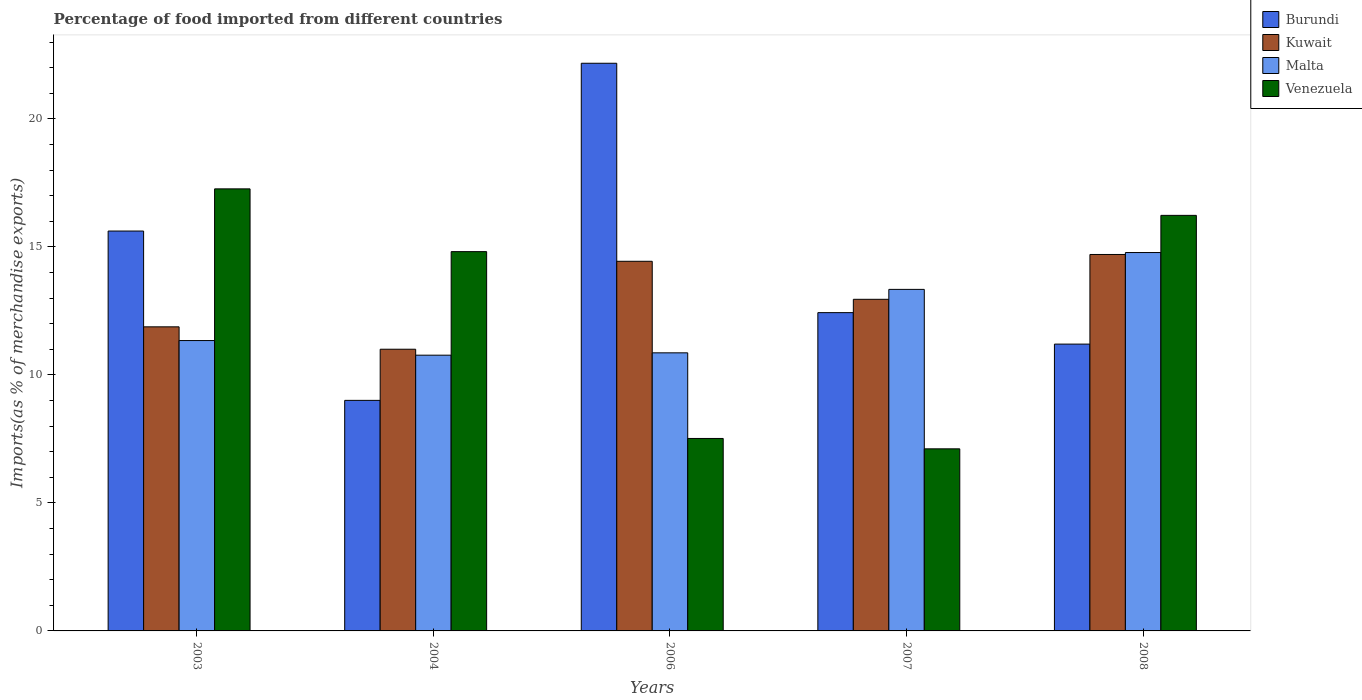How many groups of bars are there?
Make the answer very short. 5. Are the number of bars on each tick of the X-axis equal?
Ensure brevity in your answer.  Yes. How many bars are there on the 2nd tick from the right?
Your response must be concise. 4. What is the label of the 3rd group of bars from the left?
Your answer should be compact. 2006. In how many cases, is the number of bars for a given year not equal to the number of legend labels?
Provide a succinct answer. 0. What is the percentage of imports to different countries in Malta in 2003?
Ensure brevity in your answer.  11.34. Across all years, what is the maximum percentage of imports to different countries in Burundi?
Your answer should be compact. 22.17. Across all years, what is the minimum percentage of imports to different countries in Burundi?
Keep it short and to the point. 9. In which year was the percentage of imports to different countries in Venezuela minimum?
Provide a short and direct response. 2007. What is the total percentage of imports to different countries in Kuwait in the graph?
Provide a succinct answer. 64.97. What is the difference between the percentage of imports to different countries in Kuwait in 2004 and that in 2008?
Make the answer very short. -3.7. What is the difference between the percentage of imports to different countries in Kuwait in 2007 and the percentage of imports to different countries in Burundi in 2008?
Your answer should be very brief. 1.75. What is the average percentage of imports to different countries in Kuwait per year?
Offer a very short reply. 12.99. In the year 2008, what is the difference between the percentage of imports to different countries in Burundi and percentage of imports to different countries in Venezuela?
Your answer should be very brief. -5.03. In how many years, is the percentage of imports to different countries in Venezuela greater than 1 %?
Ensure brevity in your answer.  5. What is the ratio of the percentage of imports to different countries in Kuwait in 2006 to that in 2008?
Offer a very short reply. 0.98. Is the difference between the percentage of imports to different countries in Burundi in 2004 and 2008 greater than the difference between the percentage of imports to different countries in Venezuela in 2004 and 2008?
Ensure brevity in your answer.  No. What is the difference between the highest and the second highest percentage of imports to different countries in Burundi?
Give a very brief answer. 6.55. What is the difference between the highest and the lowest percentage of imports to different countries in Kuwait?
Give a very brief answer. 3.7. What does the 3rd bar from the left in 2008 represents?
Provide a short and direct response. Malta. What does the 2nd bar from the right in 2006 represents?
Give a very brief answer. Malta. How many bars are there?
Keep it short and to the point. 20. Are the values on the major ticks of Y-axis written in scientific E-notation?
Make the answer very short. No. Does the graph contain any zero values?
Give a very brief answer. No. Where does the legend appear in the graph?
Your answer should be very brief. Top right. How many legend labels are there?
Provide a short and direct response. 4. How are the legend labels stacked?
Your response must be concise. Vertical. What is the title of the graph?
Make the answer very short. Percentage of food imported from different countries. Does "Timor-Leste" appear as one of the legend labels in the graph?
Your answer should be compact. No. What is the label or title of the Y-axis?
Provide a short and direct response. Imports(as % of merchandise exports). What is the Imports(as % of merchandise exports) of Burundi in 2003?
Provide a succinct answer. 15.62. What is the Imports(as % of merchandise exports) in Kuwait in 2003?
Offer a very short reply. 11.88. What is the Imports(as % of merchandise exports) of Malta in 2003?
Provide a short and direct response. 11.34. What is the Imports(as % of merchandise exports) in Venezuela in 2003?
Provide a succinct answer. 17.26. What is the Imports(as % of merchandise exports) of Burundi in 2004?
Provide a short and direct response. 9. What is the Imports(as % of merchandise exports) in Kuwait in 2004?
Your answer should be compact. 11. What is the Imports(as % of merchandise exports) in Malta in 2004?
Your answer should be very brief. 10.77. What is the Imports(as % of merchandise exports) in Venezuela in 2004?
Give a very brief answer. 14.81. What is the Imports(as % of merchandise exports) in Burundi in 2006?
Offer a terse response. 22.17. What is the Imports(as % of merchandise exports) of Kuwait in 2006?
Make the answer very short. 14.44. What is the Imports(as % of merchandise exports) in Malta in 2006?
Offer a very short reply. 10.86. What is the Imports(as % of merchandise exports) in Venezuela in 2006?
Your answer should be very brief. 7.52. What is the Imports(as % of merchandise exports) in Burundi in 2007?
Ensure brevity in your answer.  12.43. What is the Imports(as % of merchandise exports) in Kuwait in 2007?
Your answer should be compact. 12.95. What is the Imports(as % of merchandise exports) of Malta in 2007?
Offer a very short reply. 13.34. What is the Imports(as % of merchandise exports) of Venezuela in 2007?
Offer a very short reply. 7.11. What is the Imports(as % of merchandise exports) in Burundi in 2008?
Give a very brief answer. 11.2. What is the Imports(as % of merchandise exports) in Kuwait in 2008?
Give a very brief answer. 14.7. What is the Imports(as % of merchandise exports) of Malta in 2008?
Keep it short and to the point. 14.78. What is the Imports(as % of merchandise exports) in Venezuela in 2008?
Keep it short and to the point. 16.23. Across all years, what is the maximum Imports(as % of merchandise exports) of Burundi?
Your answer should be very brief. 22.17. Across all years, what is the maximum Imports(as % of merchandise exports) of Kuwait?
Offer a very short reply. 14.7. Across all years, what is the maximum Imports(as % of merchandise exports) of Malta?
Give a very brief answer. 14.78. Across all years, what is the maximum Imports(as % of merchandise exports) in Venezuela?
Your answer should be very brief. 17.26. Across all years, what is the minimum Imports(as % of merchandise exports) of Burundi?
Make the answer very short. 9. Across all years, what is the minimum Imports(as % of merchandise exports) of Kuwait?
Provide a short and direct response. 11. Across all years, what is the minimum Imports(as % of merchandise exports) of Malta?
Provide a succinct answer. 10.77. Across all years, what is the minimum Imports(as % of merchandise exports) in Venezuela?
Your response must be concise. 7.11. What is the total Imports(as % of merchandise exports) of Burundi in the graph?
Offer a very short reply. 70.42. What is the total Imports(as % of merchandise exports) in Kuwait in the graph?
Your response must be concise. 64.97. What is the total Imports(as % of merchandise exports) of Malta in the graph?
Your answer should be compact. 61.09. What is the total Imports(as % of merchandise exports) in Venezuela in the graph?
Make the answer very short. 62.94. What is the difference between the Imports(as % of merchandise exports) in Burundi in 2003 and that in 2004?
Offer a terse response. 6.61. What is the difference between the Imports(as % of merchandise exports) in Kuwait in 2003 and that in 2004?
Provide a short and direct response. 0.87. What is the difference between the Imports(as % of merchandise exports) of Malta in 2003 and that in 2004?
Offer a terse response. 0.57. What is the difference between the Imports(as % of merchandise exports) of Venezuela in 2003 and that in 2004?
Make the answer very short. 2.45. What is the difference between the Imports(as % of merchandise exports) in Burundi in 2003 and that in 2006?
Provide a succinct answer. -6.55. What is the difference between the Imports(as % of merchandise exports) in Kuwait in 2003 and that in 2006?
Your answer should be very brief. -2.56. What is the difference between the Imports(as % of merchandise exports) of Malta in 2003 and that in 2006?
Keep it short and to the point. 0.48. What is the difference between the Imports(as % of merchandise exports) of Venezuela in 2003 and that in 2006?
Offer a very short reply. 9.75. What is the difference between the Imports(as % of merchandise exports) of Burundi in 2003 and that in 2007?
Provide a succinct answer. 3.19. What is the difference between the Imports(as % of merchandise exports) of Kuwait in 2003 and that in 2007?
Give a very brief answer. -1.08. What is the difference between the Imports(as % of merchandise exports) of Malta in 2003 and that in 2007?
Make the answer very short. -2. What is the difference between the Imports(as % of merchandise exports) of Venezuela in 2003 and that in 2007?
Your answer should be compact. 10.15. What is the difference between the Imports(as % of merchandise exports) in Burundi in 2003 and that in 2008?
Keep it short and to the point. 4.42. What is the difference between the Imports(as % of merchandise exports) of Kuwait in 2003 and that in 2008?
Provide a succinct answer. -2.83. What is the difference between the Imports(as % of merchandise exports) of Malta in 2003 and that in 2008?
Give a very brief answer. -3.44. What is the difference between the Imports(as % of merchandise exports) in Venezuela in 2003 and that in 2008?
Give a very brief answer. 1.03. What is the difference between the Imports(as % of merchandise exports) in Burundi in 2004 and that in 2006?
Provide a succinct answer. -13.17. What is the difference between the Imports(as % of merchandise exports) in Kuwait in 2004 and that in 2006?
Offer a terse response. -3.43. What is the difference between the Imports(as % of merchandise exports) in Malta in 2004 and that in 2006?
Provide a short and direct response. -0.09. What is the difference between the Imports(as % of merchandise exports) of Venezuela in 2004 and that in 2006?
Provide a short and direct response. 7.3. What is the difference between the Imports(as % of merchandise exports) in Burundi in 2004 and that in 2007?
Your answer should be compact. -3.43. What is the difference between the Imports(as % of merchandise exports) in Kuwait in 2004 and that in 2007?
Keep it short and to the point. -1.95. What is the difference between the Imports(as % of merchandise exports) of Malta in 2004 and that in 2007?
Your answer should be very brief. -2.57. What is the difference between the Imports(as % of merchandise exports) of Venezuela in 2004 and that in 2007?
Offer a very short reply. 7.7. What is the difference between the Imports(as % of merchandise exports) of Burundi in 2004 and that in 2008?
Offer a terse response. -2.2. What is the difference between the Imports(as % of merchandise exports) in Kuwait in 2004 and that in 2008?
Provide a succinct answer. -3.7. What is the difference between the Imports(as % of merchandise exports) in Malta in 2004 and that in 2008?
Offer a very short reply. -4.01. What is the difference between the Imports(as % of merchandise exports) of Venezuela in 2004 and that in 2008?
Provide a short and direct response. -1.42. What is the difference between the Imports(as % of merchandise exports) of Burundi in 2006 and that in 2007?
Give a very brief answer. 9.74. What is the difference between the Imports(as % of merchandise exports) in Kuwait in 2006 and that in 2007?
Keep it short and to the point. 1.48. What is the difference between the Imports(as % of merchandise exports) in Malta in 2006 and that in 2007?
Offer a terse response. -2.48. What is the difference between the Imports(as % of merchandise exports) of Venezuela in 2006 and that in 2007?
Ensure brevity in your answer.  0.41. What is the difference between the Imports(as % of merchandise exports) of Burundi in 2006 and that in 2008?
Give a very brief answer. 10.97. What is the difference between the Imports(as % of merchandise exports) in Kuwait in 2006 and that in 2008?
Offer a very short reply. -0.27. What is the difference between the Imports(as % of merchandise exports) in Malta in 2006 and that in 2008?
Offer a terse response. -3.92. What is the difference between the Imports(as % of merchandise exports) of Venezuela in 2006 and that in 2008?
Your answer should be compact. -8.71. What is the difference between the Imports(as % of merchandise exports) of Burundi in 2007 and that in 2008?
Offer a very short reply. 1.23. What is the difference between the Imports(as % of merchandise exports) of Kuwait in 2007 and that in 2008?
Ensure brevity in your answer.  -1.75. What is the difference between the Imports(as % of merchandise exports) in Malta in 2007 and that in 2008?
Offer a very short reply. -1.44. What is the difference between the Imports(as % of merchandise exports) in Venezuela in 2007 and that in 2008?
Your response must be concise. -9.12. What is the difference between the Imports(as % of merchandise exports) of Burundi in 2003 and the Imports(as % of merchandise exports) of Kuwait in 2004?
Make the answer very short. 4.62. What is the difference between the Imports(as % of merchandise exports) in Burundi in 2003 and the Imports(as % of merchandise exports) in Malta in 2004?
Your answer should be very brief. 4.85. What is the difference between the Imports(as % of merchandise exports) of Burundi in 2003 and the Imports(as % of merchandise exports) of Venezuela in 2004?
Offer a terse response. 0.8. What is the difference between the Imports(as % of merchandise exports) in Kuwait in 2003 and the Imports(as % of merchandise exports) in Malta in 2004?
Make the answer very short. 1.11. What is the difference between the Imports(as % of merchandise exports) of Kuwait in 2003 and the Imports(as % of merchandise exports) of Venezuela in 2004?
Offer a terse response. -2.94. What is the difference between the Imports(as % of merchandise exports) in Malta in 2003 and the Imports(as % of merchandise exports) in Venezuela in 2004?
Your answer should be very brief. -3.47. What is the difference between the Imports(as % of merchandise exports) in Burundi in 2003 and the Imports(as % of merchandise exports) in Kuwait in 2006?
Your answer should be very brief. 1.18. What is the difference between the Imports(as % of merchandise exports) of Burundi in 2003 and the Imports(as % of merchandise exports) of Malta in 2006?
Offer a terse response. 4.76. What is the difference between the Imports(as % of merchandise exports) of Burundi in 2003 and the Imports(as % of merchandise exports) of Venezuela in 2006?
Ensure brevity in your answer.  8.1. What is the difference between the Imports(as % of merchandise exports) in Kuwait in 2003 and the Imports(as % of merchandise exports) in Malta in 2006?
Ensure brevity in your answer.  1.02. What is the difference between the Imports(as % of merchandise exports) in Kuwait in 2003 and the Imports(as % of merchandise exports) in Venezuela in 2006?
Give a very brief answer. 4.36. What is the difference between the Imports(as % of merchandise exports) in Malta in 2003 and the Imports(as % of merchandise exports) in Venezuela in 2006?
Your response must be concise. 3.82. What is the difference between the Imports(as % of merchandise exports) of Burundi in 2003 and the Imports(as % of merchandise exports) of Kuwait in 2007?
Your answer should be very brief. 2.67. What is the difference between the Imports(as % of merchandise exports) in Burundi in 2003 and the Imports(as % of merchandise exports) in Malta in 2007?
Ensure brevity in your answer.  2.28. What is the difference between the Imports(as % of merchandise exports) of Burundi in 2003 and the Imports(as % of merchandise exports) of Venezuela in 2007?
Offer a terse response. 8.51. What is the difference between the Imports(as % of merchandise exports) of Kuwait in 2003 and the Imports(as % of merchandise exports) of Malta in 2007?
Offer a very short reply. -1.46. What is the difference between the Imports(as % of merchandise exports) in Kuwait in 2003 and the Imports(as % of merchandise exports) in Venezuela in 2007?
Offer a very short reply. 4.76. What is the difference between the Imports(as % of merchandise exports) in Malta in 2003 and the Imports(as % of merchandise exports) in Venezuela in 2007?
Keep it short and to the point. 4.23. What is the difference between the Imports(as % of merchandise exports) in Burundi in 2003 and the Imports(as % of merchandise exports) in Kuwait in 2008?
Your answer should be compact. 0.92. What is the difference between the Imports(as % of merchandise exports) of Burundi in 2003 and the Imports(as % of merchandise exports) of Malta in 2008?
Provide a short and direct response. 0.84. What is the difference between the Imports(as % of merchandise exports) of Burundi in 2003 and the Imports(as % of merchandise exports) of Venezuela in 2008?
Ensure brevity in your answer.  -0.61. What is the difference between the Imports(as % of merchandise exports) of Kuwait in 2003 and the Imports(as % of merchandise exports) of Malta in 2008?
Make the answer very short. -2.9. What is the difference between the Imports(as % of merchandise exports) in Kuwait in 2003 and the Imports(as % of merchandise exports) in Venezuela in 2008?
Give a very brief answer. -4.35. What is the difference between the Imports(as % of merchandise exports) of Malta in 2003 and the Imports(as % of merchandise exports) of Venezuela in 2008?
Offer a terse response. -4.89. What is the difference between the Imports(as % of merchandise exports) of Burundi in 2004 and the Imports(as % of merchandise exports) of Kuwait in 2006?
Ensure brevity in your answer.  -5.43. What is the difference between the Imports(as % of merchandise exports) of Burundi in 2004 and the Imports(as % of merchandise exports) of Malta in 2006?
Give a very brief answer. -1.86. What is the difference between the Imports(as % of merchandise exports) of Burundi in 2004 and the Imports(as % of merchandise exports) of Venezuela in 2006?
Ensure brevity in your answer.  1.49. What is the difference between the Imports(as % of merchandise exports) of Kuwait in 2004 and the Imports(as % of merchandise exports) of Malta in 2006?
Offer a very short reply. 0.14. What is the difference between the Imports(as % of merchandise exports) in Kuwait in 2004 and the Imports(as % of merchandise exports) in Venezuela in 2006?
Provide a succinct answer. 3.49. What is the difference between the Imports(as % of merchandise exports) in Malta in 2004 and the Imports(as % of merchandise exports) in Venezuela in 2006?
Provide a short and direct response. 3.25. What is the difference between the Imports(as % of merchandise exports) in Burundi in 2004 and the Imports(as % of merchandise exports) in Kuwait in 2007?
Offer a very short reply. -3.95. What is the difference between the Imports(as % of merchandise exports) of Burundi in 2004 and the Imports(as % of merchandise exports) of Malta in 2007?
Offer a terse response. -4.33. What is the difference between the Imports(as % of merchandise exports) in Burundi in 2004 and the Imports(as % of merchandise exports) in Venezuela in 2007?
Offer a very short reply. 1.89. What is the difference between the Imports(as % of merchandise exports) of Kuwait in 2004 and the Imports(as % of merchandise exports) of Malta in 2007?
Your response must be concise. -2.34. What is the difference between the Imports(as % of merchandise exports) in Kuwait in 2004 and the Imports(as % of merchandise exports) in Venezuela in 2007?
Your answer should be compact. 3.89. What is the difference between the Imports(as % of merchandise exports) of Malta in 2004 and the Imports(as % of merchandise exports) of Venezuela in 2007?
Your answer should be very brief. 3.66. What is the difference between the Imports(as % of merchandise exports) in Burundi in 2004 and the Imports(as % of merchandise exports) in Kuwait in 2008?
Provide a short and direct response. -5.7. What is the difference between the Imports(as % of merchandise exports) in Burundi in 2004 and the Imports(as % of merchandise exports) in Malta in 2008?
Your answer should be compact. -5.77. What is the difference between the Imports(as % of merchandise exports) of Burundi in 2004 and the Imports(as % of merchandise exports) of Venezuela in 2008?
Provide a short and direct response. -7.23. What is the difference between the Imports(as % of merchandise exports) of Kuwait in 2004 and the Imports(as % of merchandise exports) of Malta in 2008?
Provide a succinct answer. -3.78. What is the difference between the Imports(as % of merchandise exports) in Kuwait in 2004 and the Imports(as % of merchandise exports) in Venezuela in 2008?
Offer a terse response. -5.23. What is the difference between the Imports(as % of merchandise exports) of Malta in 2004 and the Imports(as % of merchandise exports) of Venezuela in 2008?
Your answer should be compact. -5.46. What is the difference between the Imports(as % of merchandise exports) of Burundi in 2006 and the Imports(as % of merchandise exports) of Kuwait in 2007?
Offer a terse response. 9.22. What is the difference between the Imports(as % of merchandise exports) in Burundi in 2006 and the Imports(as % of merchandise exports) in Malta in 2007?
Provide a short and direct response. 8.83. What is the difference between the Imports(as % of merchandise exports) of Burundi in 2006 and the Imports(as % of merchandise exports) of Venezuela in 2007?
Offer a terse response. 15.06. What is the difference between the Imports(as % of merchandise exports) in Kuwait in 2006 and the Imports(as % of merchandise exports) in Malta in 2007?
Your response must be concise. 1.1. What is the difference between the Imports(as % of merchandise exports) of Kuwait in 2006 and the Imports(as % of merchandise exports) of Venezuela in 2007?
Give a very brief answer. 7.32. What is the difference between the Imports(as % of merchandise exports) in Malta in 2006 and the Imports(as % of merchandise exports) in Venezuela in 2007?
Give a very brief answer. 3.75. What is the difference between the Imports(as % of merchandise exports) of Burundi in 2006 and the Imports(as % of merchandise exports) of Kuwait in 2008?
Your response must be concise. 7.47. What is the difference between the Imports(as % of merchandise exports) in Burundi in 2006 and the Imports(as % of merchandise exports) in Malta in 2008?
Ensure brevity in your answer.  7.39. What is the difference between the Imports(as % of merchandise exports) of Burundi in 2006 and the Imports(as % of merchandise exports) of Venezuela in 2008?
Provide a succinct answer. 5.94. What is the difference between the Imports(as % of merchandise exports) of Kuwait in 2006 and the Imports(as % of merchandise exports) of Malta in 2008?
Give a very brief answer. -0.34. What is the difference between the Imports(as % of merchandise exports) in Kuwait in 2006 and the Imports(as % of merchandise exports) in Venezuela in 2008?
Make the answer very short. -1.79. What is the difference between the Imports(as % of merchandise exports) in Malta in 2006 and the Imports(as % of merchandise exports) in Venezuela in 2008?
Ensure brevity in your answer.  -5.37. What is the difference between the Imports(as % of merchandise exports) in Burundi in 2007 and the Imports(as % of merchandise exports) in Kuwait in 2008?
Your answer should be very brief. -2.27. What is the difference between the Imports(as % of merchandise exports) in Burundi in 2007 and the Imports(as % of merchandise exports) in Malta in 2008?
Give a very brief answer. -2.35. What is the difference between the Imports(as % of merchandise exports) of Burundi in 2007 and the Imports(as % of merchandise exports) of Venezuela in 2008?
Offer a terse response. -3.8. What is the difference between the Imports(as % of merchandise exports) in Kuwait in 2007 and the Imports(as % of merchandise exports) in Malta in 2008?
Your answer should be compact. -1.83. What is the difference between the Imports(as % of merchandise exports) of Kuwait in 2007 and the Imports(as % of merchandise exports) of Venezuela in 2008?
Ensure brevity in your answer.  -3.28. What is the difference between the Imports(as % of merchandise exports) in Malta in 2007 and the Imports(as % of merchandise exports) in Venezuela in 2008?
Keep it short and to the point. -2.89. What is the average Imports(as % of merchandise exports) of Burundi per year?
Provide a succinct answer. 14.08. What is the average Imports(as % of merchandise exports) in Kuwait per year?
Provide a short and direct response. 12.99. What is the average Imports(as % of merchandise exports) in Malta per year?
Offer a very short reply. 12.22. What is the average Imports(as % of merchandise exports) of Venezuela per year?
Ensure brevity in your answer.  12.59. In the year 2003, what is the difference between the Imports(as % of merchandise exports) of Burundi and Imports(as % of merchandise exports) of Kuwait?
Offer a very short reply. 3.74. In the year 2003, what is the difference between the Imports(as % of merchandise exports) in Burundi and Imports(as % of merchandise exports) in Malta?
Keep it short and to the point. 4.28. In the year 2003, what is the difference between the Imports(as % of merchandise exports) of Burundi and Imports(as % of merchandise exports) of Venezuela?
Provide a short and direct response. -1.65. In the year 2003, what is the difference between the Imports(as % of merchandise exports) in Kuwait and Imports(as % of merchandise exports) in Malta?
Ensure brevity in your answer.  0.54. In the year 2003, what is the difference between the Imports(as % of merchandise exports) in Kuwait and Imports(as % of merchandise exports) in Venezuela?
Provide a succinct answer. -5.39. In the year 2003, what is the difference between the Imports(as % of merchandise exports) of Malta and Imports(as % of merchandise exports) of Venezuela?
Your response must be concise. -5.92. In the year 2004, what is the difference between the Imports(as % of merchandise exports) in Burundi and Imports(as % of merchandise exports) in Kuwait?
Keep it short and to the point. -2. In the year 2004, what is the difference between the Imports(as % of merchandise exports) in Burundi and Imports(as % of merchandise exports) in Malta?
Your answer should be compact. -1.76. In the year 2004, what is the difference between the Imports(as % of merchandise exports) of Burundi and Imports(as % of merchandise exports) of Venezuela?
Your answer should be compact. -5.81. In the year 2004, what is the difference between the Imports(as % of merchandise exports) in Kuwait and Imports(as % of merchandise exports) in Malta?
Your answer should be compact. 0.23. In the year 2004, what is the difference between the Imports(as % of merchandise exports) in Kuwait and Imports(as % of merchandise exports) in Venezuela?
Provide a succinct answer. -3.81. In the year 2004, what is the difference between the Imports(as % of merchandise exports) in Malta and Imports(as % of merchandise exports) in Venezuela?
Your response must be concise. -4.04. In the year 2006, what is the difference between the Imports(as % of merchandise exports) of Burundi and Imports(as % of merchandise exports) of Kuwait?
Provide a short and direct response. 7.73. In the year 2006, what is the difference between the Imports(as % of merchandise exports) of Burundi and Imports(as % of merchandise exports) of Malta?
Keep it short and to the point. 11.31. In the year 2006, what is the difference between the Imports(as % of merchandise exports) in Burundi and Imports(as % of merchandise exports) in Venezuela?
Your response must be concise. 14.65. In the year 2006, what is the difference between the Imports(as % of merchandise exports) in Kuwait and Imports(as % of merchandise exports) in Malta?
Give a very brief answer. 3.58. In the year 2006, what is the difference between the Imports(as % of merchandise exports) of Kuwait and Imports(as % of merchandise exports) of Venezuela?
Offer a very short reply. 6.92. In the year 2006, what is the difference between the Imports(as % of merchandise exports) in Malta and Imports(as % of merchandise exports) in Venezuela?
Provide a short and direct response. 3.34. In the year 2007, what is the difference between the Imports(as % of merchandise exports) in Burundi and Imports(as % of merchandise exports) in Kuwait?
Your response must be concise. -0.52. In the year 2007, what is the difference between the Imports(as % of merchandise exports) in Burundi and Imports(as % of merchandise exports) in Malta?
Your answer should be very brief. -0.91. In the year 2007, what is the difference between the Imports(as % of merchandise exports) in Burundi and Imports(as % of merchandise exports) in Venezuela?
Provide a succinct answer. 5.32. In the year 2007, what is the difference between the Imports(as % of merchandise exports) in Kuwait and Imports(as % of merchandise exports) in Malta?
Provide a succinct answer. -0.39. In the year 2007, what is the difference between the Imports(as % of merchandise exports) of Kuwait and Imports(as % of merchandise exports) of Venezuela?
Ensure brevity in your answer.  5.84. In the year 2007, what is the difference between the Imports(as % of merchandise exports) in Malta and Imports(as % of merchandise exports) in Venezuela?
Make the answer very short. 6.23. In the year 2008, what is the difference between the Imports(as % of merchandise exports) in Burundi and Imports(as % of merchandise exports) in Kuwait?
Offer a very short reply. -3.5. In the year 2008, what is the difference between the Imports(as % of merchandise exports) of Burundi and Imports(as % of merchandise exports) of Malta?
Provide a succinct answer. -3.58. In the year 2008, what is the difference between the Imports(as % of merchandise exports) in Burundi and Imports(as % of merchandise exports) in Venezuela?
Offer a very short reply. -5.03. In the year 2008, what is the difference between the Imports(as % of merchandise exports) in Kuwait and Imports(as % of merchandise exports) in Malta?
Offer a very short reply. -0.08. In the year 2008, what is the difference between the Imports(as % of merchandise exports) of Kuwait and Imports(as % of merchandise exports) of Venezuela?
Keep it short and to the point. -1.53. In the year 2008, what is the difference between the Imports(as % of merchandise exports) of Malta and Imports(as % of merchandise exports) of Venezuela?
Make the answer very short. -1.45. What is the ratio of the Imports(as % of merchandise exports) in Burundi in 2003 to that in 2004?
Provide a short and direct response. 1.73. What is the ratio of the Imports(as % of merchandise exports) of Kuwait in 2003 to that in 2004?
Your answer should be very brief. 1.08. What is the ratio of the Imports(as % of merchandise exports) in Malta in 2003 to that in 2004?
Offer a terse response. 1.05. What is the ratio of the Imports(as % of merchandise exports) in Venezuela in 2003 to that in 2004?
Provide a short and direct response. 1.17. What is the ratio of the Imports(as % of merchandise exports) of Burundi in 2003 to that in 2006?
Give a very brief answer. 0.7. What is the ratio of the Imports(as % of merchandise exports) in Kuwait in 2003 to that in 2006?
Provide a short and direct response. 0.82. What is the ratio of the Imports(as % of merchandise exports) of Malta in 2003 to that in 2006?
Offer a very short reply. 1.04. What is the ratio of the Imports(as % of merchandise exports) in Venezuela in 2003 to that in 2006?
Offer a terse response. 2.3. What is the ratio of the Imports(as % of merchandise exports) of Burundi in 2003 to that in 2007?
Your response must be concise. 1.26. What is the ratio of the Imports(as % of merchandise exports) of Kuwait in 2003 to that in 2007?
Ensure brevity in your answer.  0.92. What is the ratio of the Imports(as % of merchandise exports) of Malta in 2003 to that in 2007?
Offer a very short reply. 0.85. What is the ratio of the Imports(as % of merchandise exports) in Venezuela in 2003 to that in 2007?
Offer a very short reply. 2.43. What is the ratio of the Imports(as % of merchandise exports) of Burundi in 2003 to that in 2008?
Your answer should be very brief. 1.39. What is the ratio of the Imports(as % of merchandise exports) of Kuwait in 2003 to that in 2008?
Provide a succinct answer. 0.81. What is the ratio of the Imports(as % of merchandise exports) of Malta in 2003 to that in 2008?
Provide a succinct answer. 0.77. What is the ratio of the Imports(as % of merchandise exports) of Venezuela in 2003 to that in 2008?
Give a very brief answer. 1.06. What is the ratio of the Imports(as % of merchandise exports) of Burundi in 2004 to that in 2006?
Ensure brevity in your answer.  0.41. What is the ratio of the Imports(as % of merchandise exports) in Kuwait in 2004 to that in 2006?
Offer a terse response. 0.76. What is the ratio of the Imports(as % of merchandise exports) in Venezuela in 2004 to that in 2006?
Your answer should be very brief. 1.97. What is the ratio of the Imports(as % of merchandise exports) in Burundi in 2004 to that in 2007?
Keep it short and to the point. 0.72. What is the ratio of the Imports(as % of merchandise exports) in Kuwait in 2004 to that in 2007?
Your answer should be compact. 0.85. What is the ratio of the Imports(as % of merchandise exports) of Malta in 2004 to that in 2007?
Make the answer very short. 0.81. What is the ratio of the Imports(as % of merchandise exports) in Venezuela in 2004 to that in 2007?
Ensure brevity in your answer.  2.08. What is the ratio of the Imports(as % of merchandise exports) of Burundi in 2004 to that in 2008?
Your response must be concise. 0.8. What is the ratio of the Imports(as % of merchandise exports) of Kuwait in 2004 to that in 2008?
Give a very brief answer. 0.75. What is the ratio of the Imports(as % of merchandise exports) of Malta in 2004 to that in 2008?
Your answer should be compact. 0.73. What is the ratio of the Imports(as % of merchandise exports) of Venezuela in 2004 to that in 2008?
Give a very brief answer. 0.91. What is the ratio of the Imports(as % of merchandise exports) in Burundi in 2006 to that in 2007?
Your answer should be compact. 1.78. What is the ratio of the Imports(as % of merchandise exports) of Kuwait in 2006 to that in 2007?
Your response must be concise. 1.11. What is the ratio of the Imports(as % of merchandise exports) in Malta in 2006 to that in 2007?
Provide a succinct answer. 0.81. What is the ratio of the Imports(as % of merchandise exports) of Venezuela in 2006 to that in 2007?
Provide a short and direct response. 1.06. What is the ratio of the Imports(as % of merchandise exports) in Burundi in 2006 to that in 2008?
Your response must be concise. 1.98. What is the ratio of the Imports(as % of merchandise exports) in Kuwait in 2006 to that in 2008?
Offer a very short reply. 0.98. What is the ratio of the Imports(as % of merchandise exports) in Malta in 2006 to that in 2008?
Keep it short and to the point. 0.73. What is the ratio of the Imports(as % of merchandise exports) of Venezuela in 2006 to that in 2008?
Ensure brevity in your answer.  0.46. What is the ratio of the Imports(as % of merchandise exports) in Burundi in 2007 to that in 2008?
Your response must be concise. 1.11. What is the ratio of the Imports(as % of merchandise exports) in Kuwait in 2007 to that in 2008?
Your answer should be very brief. 0.88. What is the ratio of the Imports(as % of merchandise exports) in Malta in 2007 to that in 2008?
Your answer should be very brief. 0.9. What is the ratio of the Imports(as % of merchandise exports) of Venezuela in 2007 to that in 2008?
Make the answer very short. 0.44. What is the difference between the highest and the second highest Imports(as % of merchandise exports) of Burundi?
Your answer should be very brief. 6.55. What is the difference between the highest and the second highest Imports(as % of merchandise exports) of Kuwait?
Your response must be concise. 0.27. What is the difference between the highest and the second highest Imports(as % of merchandise exports) in Malta?
Provide a short and direct response. 1.44. What is the difference between the highest and the second highest Imports(as % of merchandise exports) in Venezuela?
Provide a short and direct response. 1.03. What is the difference between the highest and the lowest Imports(as % of merchandise exports) of Burundi?
Your answer should be very brief. 13.17. What is the difference between the highest and the lowest Imports(as % of merchandise exports) of Kuwait?
Give a very brief answer. 3.7. What is the difference between the highest and the lowest Imports(as % of merchandise exports) in Malta?
Offer a very short reply. 4.01. What is the difference between the highest and the lowest Imports(as % of merchandise exports) in Venezuela?
Offer a terse response. 10.15. 